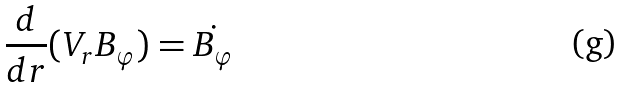<formula> <loc_0><loc_0><loc_500><loc_500>\frac { d } { d r } ( V _ { r } B _ { \varphi } ) = \dot { B _ { \varphi } }</formula> 